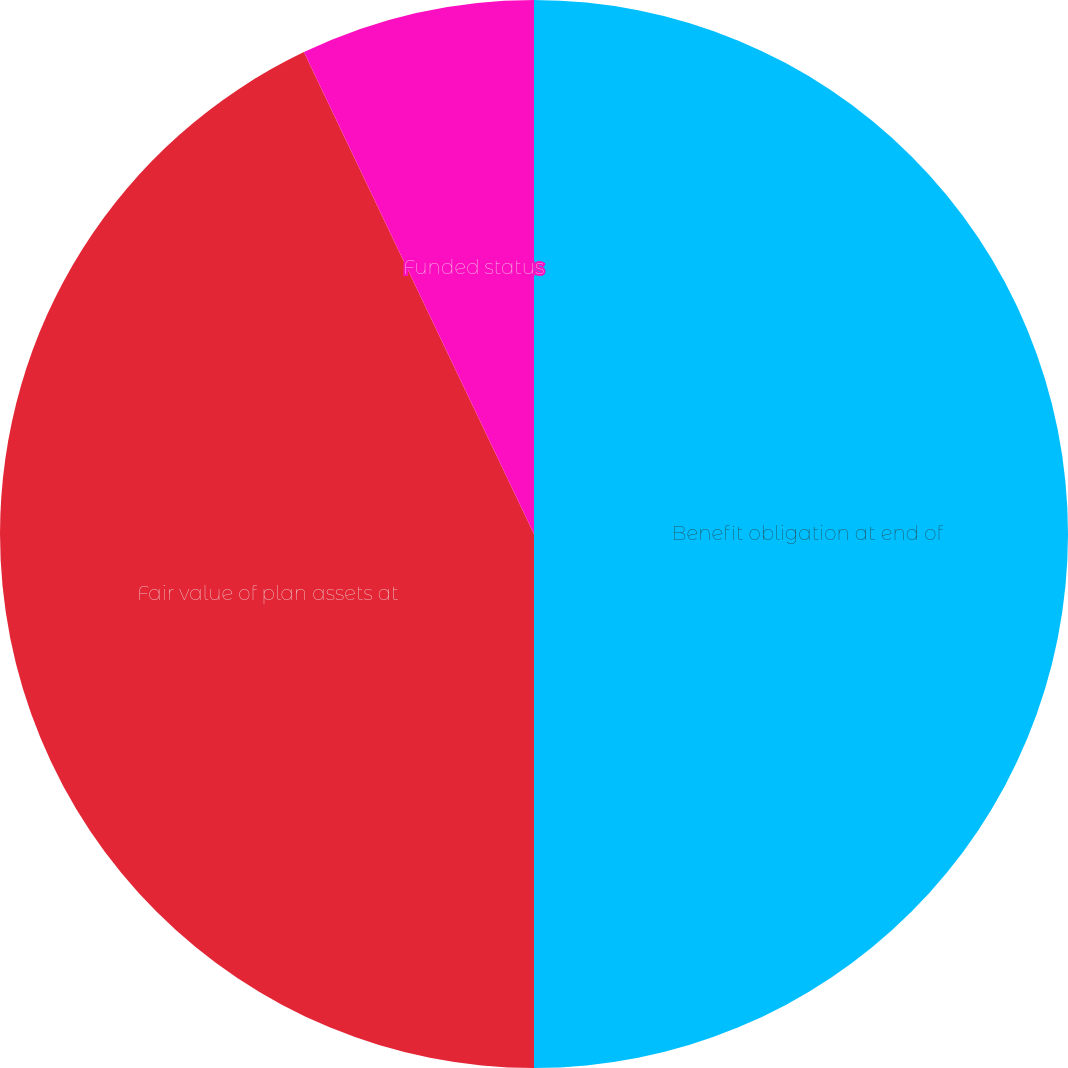Convert chart to OTSL. <chart><loc_0><loc_0><loc_500><loc_500><pie_chart><fcel>Benefit obligation at end of<fcel>Fair value of plan assets at<fcel>Funded status<nl><fcel>50.0%<fcel>42.91%<fcel>7.09%<nl></chart> 